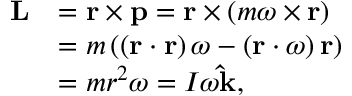<formula> <loc_0><loc_0><loc_500><loc_500>{ \begin{array} { r l } { L } & { = r \times p = r \times \left ( m { \omega } \times r \right ) } \\ & { = m \left ( \left ( r \cdot r \right ) { \omega } - \left ( r \cdot { \omega } \right ) r \right ) } \\ & { = m r ^ { 2 } { \omega } = I \omega \hat { k } , } \end{array} }</formula> 